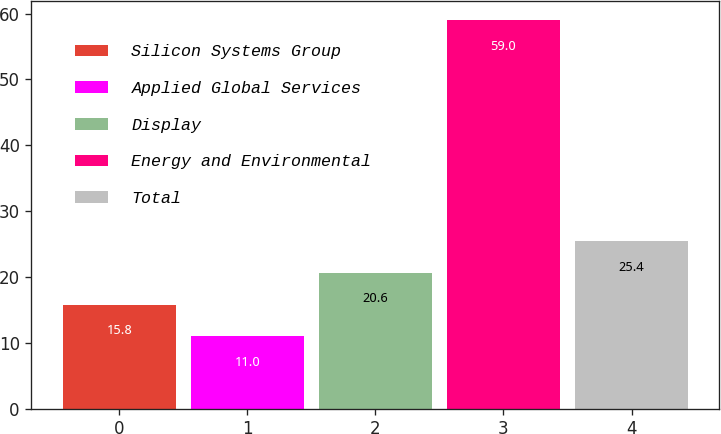Convert chart to OTSL. <chart><loc_0><loc_0><loc_500><loc_500><bar_chart><fcel>Silicon Systems Group<fcel>Applied Global Services<fcel>Display<fcel>Energy and Environmental<fcel>Total<nl><fcel>15.8<fcel>11<fcel>20.6<fcel>59<fcel>25.4<nl></chart> 